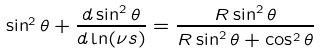Convert formula to latex. <formula><loc_0><loc_0><loc_500><loc_500>\sin ^ { 2 } \theta + \frac { d \sin ^ { 2 } \theta } { d \ln ( \nu s ) } = \frac { R \sin ^ { 2 } \theta } { R \sin ^ { 2 } \theta + \cos ^ { 2 } \theta }</formula> 